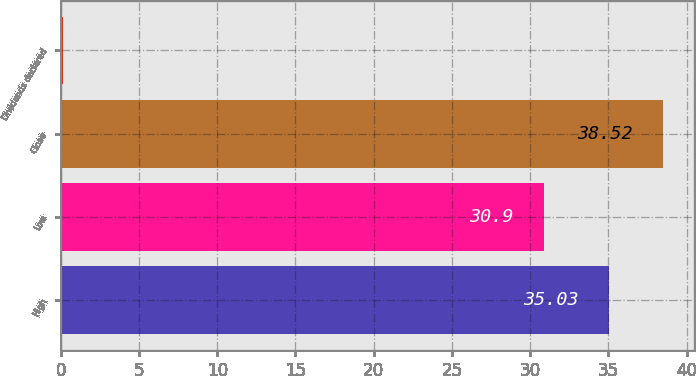Convert chart to OTSL. <chart><loc_0><loc_0><loc_500><loc_500><bar_chart><fcel>High<fcel>Low<fcel>Close<fcel>Dividends declared<nl><fcel>35.03<fcel>30.9<fcel>38.52<fcel>0.11<nl></chart> 